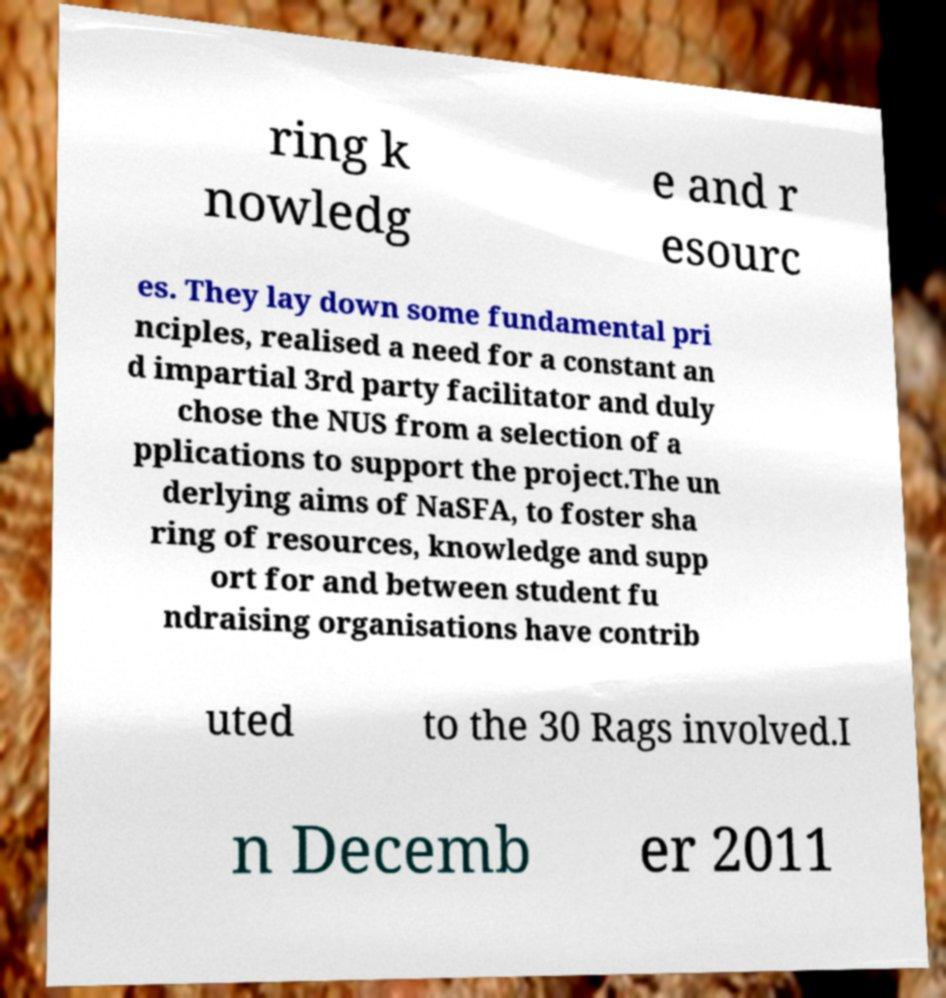Could you assist in decoding the text presented in this image and type it out clearly? ring k nowledg e and r esourc es. They lay down some fundamental pri nciples, realised a need for a constant an d impartial 3rd party facilitator and duly chose the NUS from a selection of a pplications to support the project.The un derlying aims of NaSFA, to foster sha ring of resources, knowledge and supp ort for and between student fu ndraising organisations have contrib uted to the 30 Rags involved.I n Decemb er 2011 